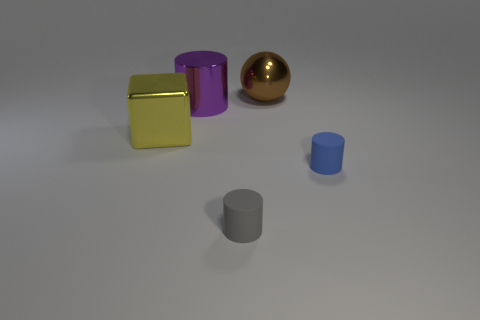The purple cylinder is what size?
Offer a terse response. Large. How big is the rubber object that is behind the matte cylinder in front of the blue matte thing?
Give a very brief answer. Small. What number of small purple cylinders are there?
Give a very brief answer. 0. How many big things are made of the same material as the large ball?
Ensure brevity in your answer.  2. There is a shiny thing that is the same shape as the gray rubber thing; what size is it?
Offer a very short reply. Large. What is the blue object made of?
Offer a terse response. Rubber. There is a small cylinder that is behind the small cylinder that is in front of the tiny matte thing that is on the right side of the brown object; what is its material?
Keep it short and to the point. Rubber. Is there any other thing that has the same shape as the big yellow thing?
Your answer should be very brief. No. The metallic thing that is the same shape as the gray matte object is what color?
Provide a short and direct response. Purple. Are there more small gray rubber objects to the right of the big cylinder than tiny brown cubes?
Offer a very short reply. Yes. 